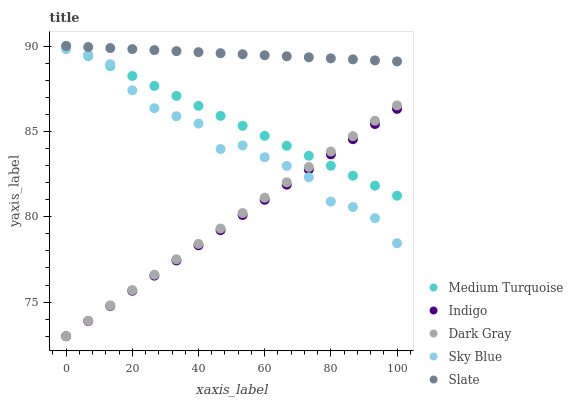Does Indigo have the minimum area under the curve?
Answer yes or no. Yes. Does Slate have the maximum area under the curve?
Answer yes or no. Yes. Does Sky Blue have the minimum area under the curve?
Answer yes or no. No. Does Sky Blue have the maximum area under the curve?
Answer yes or no. No. Is Slate the smoothest?
Answer yes or no. Yes. Is Sky Blue the roughest?
Answer yes or no. Yes. Is Sky Blue the smoothest?
Answer yes or no. No. Is Slate the roughest?
Answer yes or no. No. Does Dark Gray have the lowest value?
Answer yes or no. Yes. Does Sky Blue have the lowest value?
Answer yes or no. No. Does Medium Turquoise have the highest value?
Answer yes or no. Yes. Does Sky Blue have the highest value?
Answer yes or no. No. Is Dark Gray less than Slate?
Answer yes or no. Yes. Is Slate greater than Indigo?
Answer yes or no. Yes. Does Medium Turquoise intersect Sky Blue?
Answer yes or no. Yes. Is Medium Turquoise less than Sky Blue?
Answer yes or no. No. Is Medium Turquoise greater than Sky Blue?
Answer yes or no. No. Does Dark Gray intersect Slate?
Answer yes or no. No. 